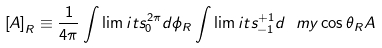<formula> <loc_0><loc_0><loc_500><loc_500>\left [ A \right ] _ { R } \equiv \frac { 1 } { 4 \pi } \int \lim i t s _ { 0 } ^ { 2 \pi } d \phi _ { R } \int \lim i t s _ { - 1 } ^ { + 1 } d \ m y \cos \theta _ { R } A</formula> 